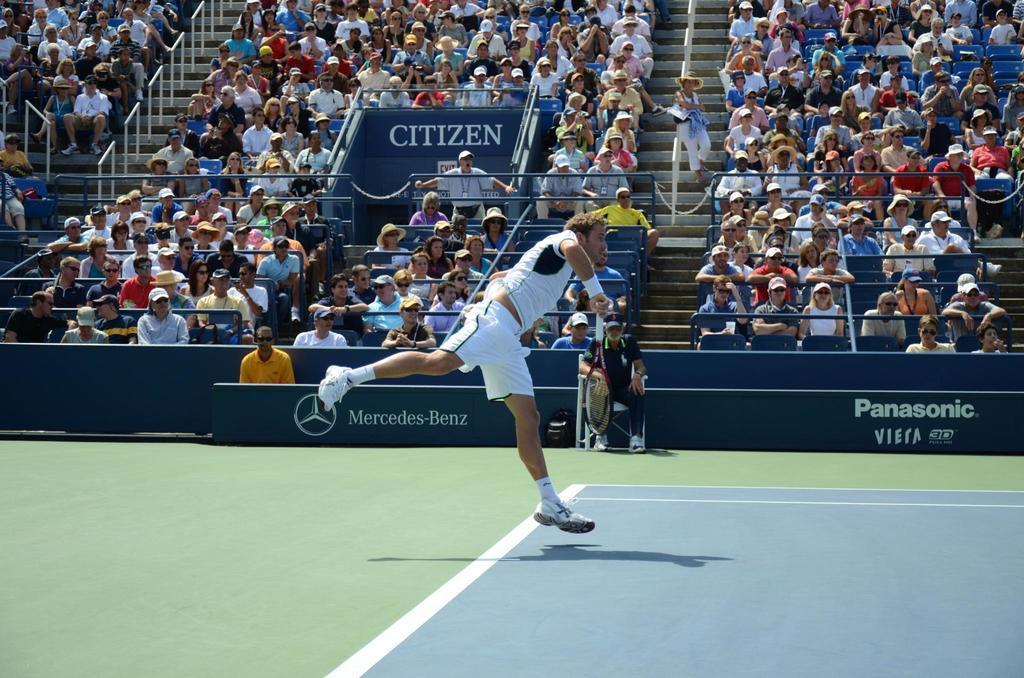Could you give a brief overview of what you see in this image? In this there is a man which is throwing something and there is audience watching that man and there is Panasonic mercedes benz written on the wall. 